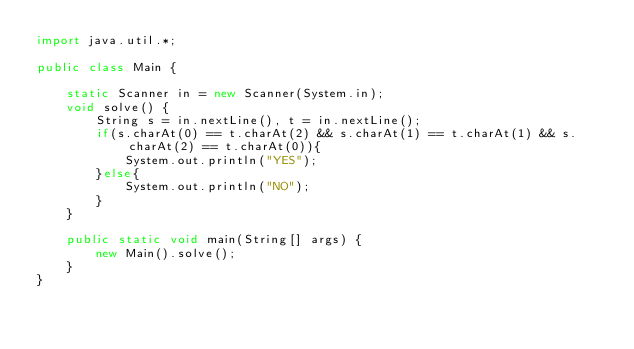<code> <loc_0><loc_0><loc_500><loc_500><_Java_>import java.util.*;

public class Main {

    static Scanner in = new Scanner(System.in);
    void solve() {
        String s = in.nextLine(), t = in.nextLine();
        if(s.charAt(0) == t.charAt(2) && s.charAt(1) == t.charAt(1) && s.charAt(2) == t.charAt(0)){
            System.out.println("YES");
        }else{
            System.out.println("NO");
        }
    }

    public static void main(String[] args) {
        new Main().solve();
    }
}</code> 